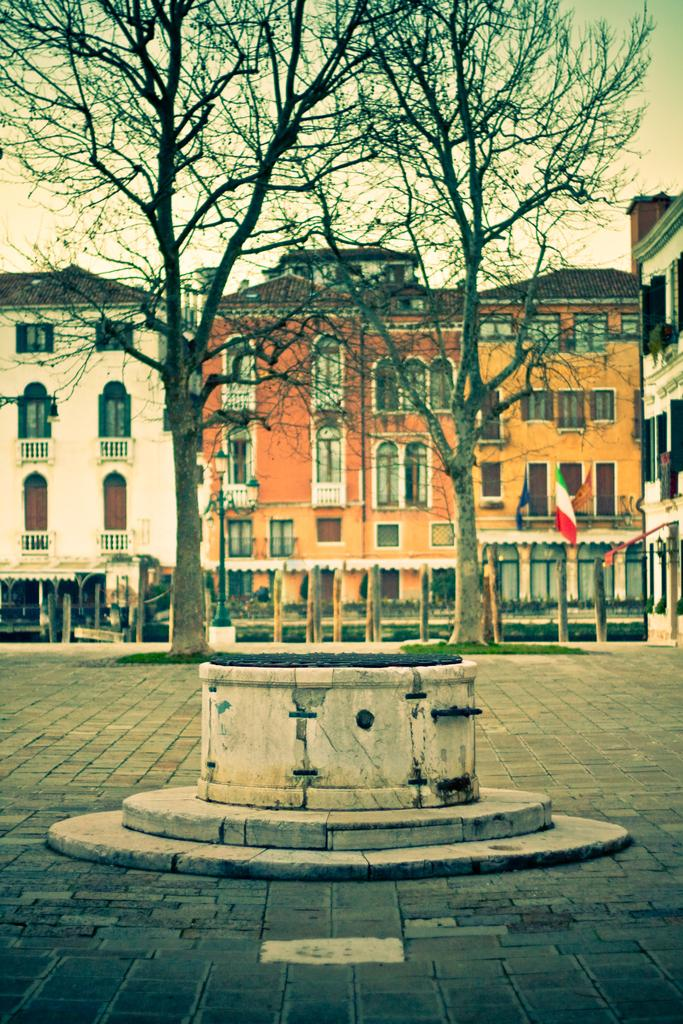What is located on the ground in the image? There is an object on the ground in the image. What can be seen in the background of the image? There are trees, a flag, sheds, buildings, and the sky visible in the background of the image. Can you see a crown on the object on the ground in the image? There is no crown present on the object on the ground in the image. What is the time of day depicted in the image? The time of day cannot be determined from the image, as there is no information about lighting or shadows to suggest whether it is day or night. 